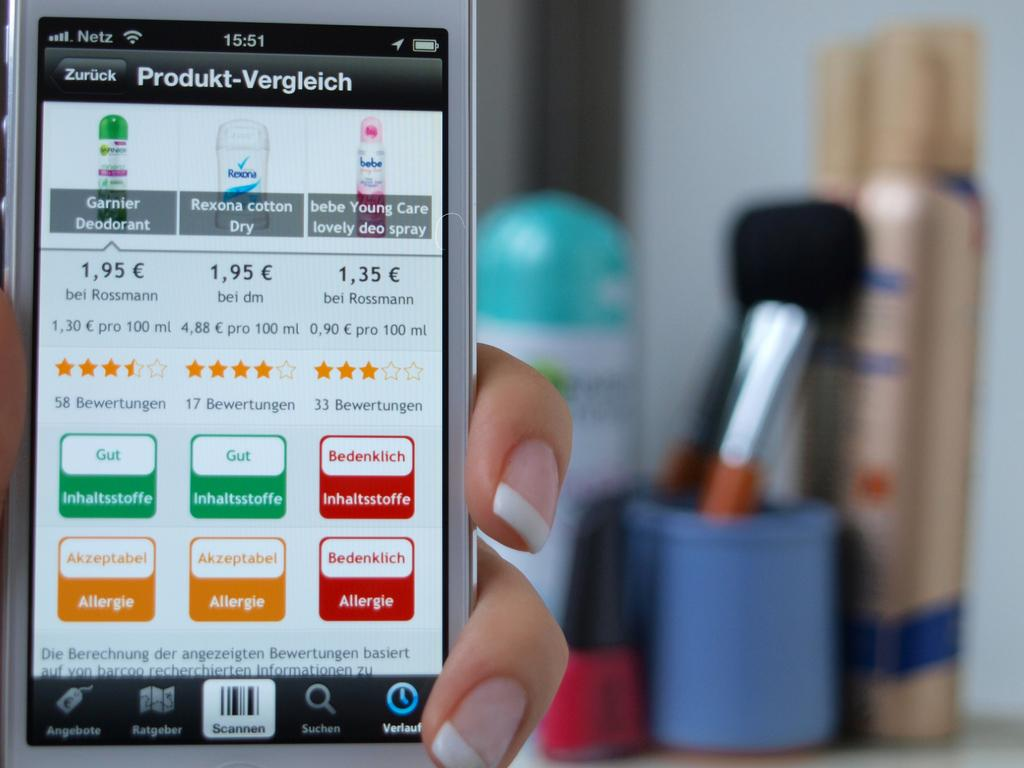What is the main subject of the image? There is a person in the image. What is the person holding in the image? The person is holding a mobile. Which part of the person is visible in the image? Only the person's hand is visible in the image. What can be seen behind the mobile in the image? There are blurred items behind the mobile. What type of background is visible in the image? There is a wall visible in the image. What type of stew is being prepared in the image? There is no stew present in the image; it only features a person holding a mobile with blurred items behind it and a wall in the background. 